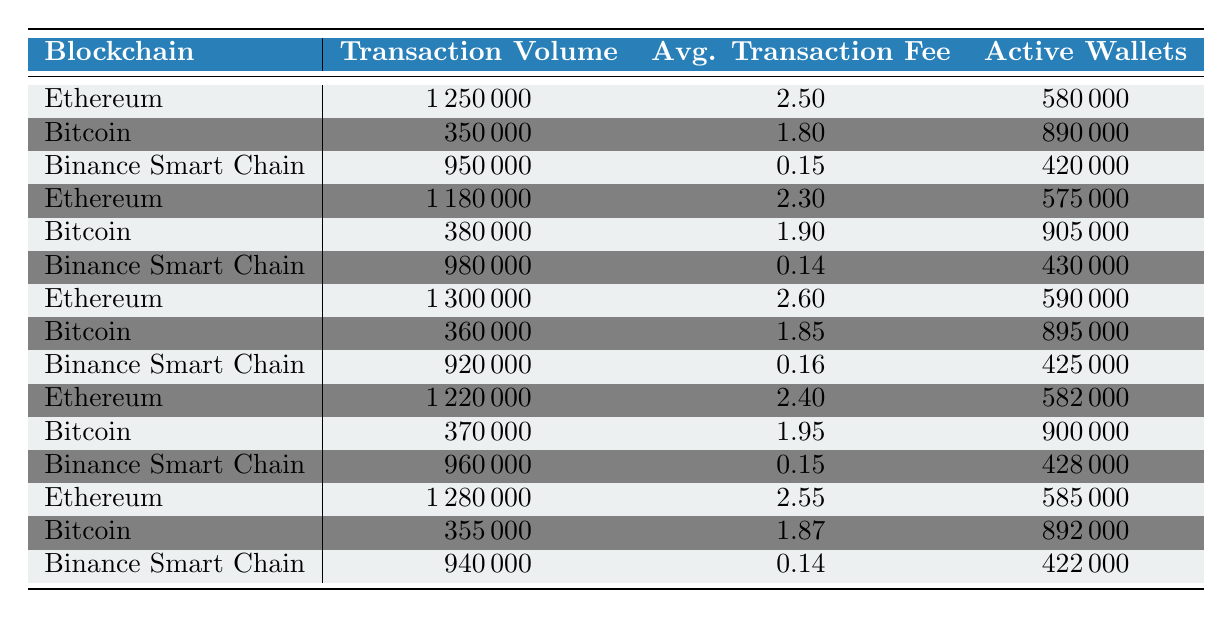What is the highest transaction volume recorded for Ethereum? By examining the transaction volumes for Ethereum across different dates in the table, the highest figure is 1,300,000, which is recorded on May 3, 2023.
Answer: 1300000 What is the average transaction fee for Bitcoin on May 2, 2023? The table lists the average transaction fee for Bitcoin on this date as 1.90.
Answer: 1.90 Which blockchain had the lowest average transaction fee overall? By comparing the average transaction fees listed for all blockchains, Binance Smart Chain has the lowest fee at 0.15.
Answer: 0.15 How many active wallets were there for Binance Smart Chain on May 1, 2023? The table shows that on May 1, 2023, Binance Smart Chain had 420,000 active wallets.
Answer: 420000 What is the total transaction volume for Binance Smart Chain over the five days? First, I will sum the transaction volumes for each day: 950000 + 980000 + 920000 + 960000 + 940000 = 4750000. Thus, the total transaction volume for Binance Smart Chain is 4,750,000.
Answer: 4750000 Is the average transaction fee for Ethereum consistently higher than for Bitcoin across the five days? By reviewing the average transaction fees, Ethereum has fees of 2.50, 2.30, 2.60, 2.40, and 2.55 while Bitcoin's fees are 1.80, 1.90, 1.85, 1.95, and 1.87. Since all Ethereum fees are greater than Bitcoin's, this statement is true.
Answer: Yes What was the average transaction volume for Ethereum over the five days? To find this average, I will sum the transaction volumes of Ethereum: 1250000 + 1180000 + 1300000 + 1220000 + 1280000 = 6210000. There are 5 entries, so the average is 6210000 / 5 = 1242000.
Answer: 1242000 Did Bitcoin's transaction volume increase or decrease from May 1 to May 5? Comparing the transaction volumes from May 1 (350000) to May 5 (355000), there is a slight increase, indicating a positive change.
Answer: Increase What was the difference in average transaction fees between Ethereum and Binance Smart Chain on May 4, 2023? The average transaction fee for Ethereum on this date is 2.40, while for Binance Smart Chain, it is 0.15. The difference is calculated by subtracting: 2.40 - 0.15 = 2.25.
Answer: 2.25 